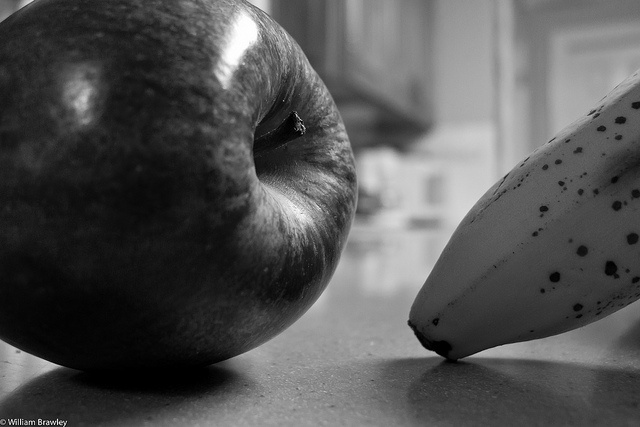Describe the objects in this image and their specific colors. I can see apple in gray, black, darkgray, and lightgray tones, dining table in gray, darkgray, black, and lightgray tones, and banana in black, gray, and darkgray tones in this image. 